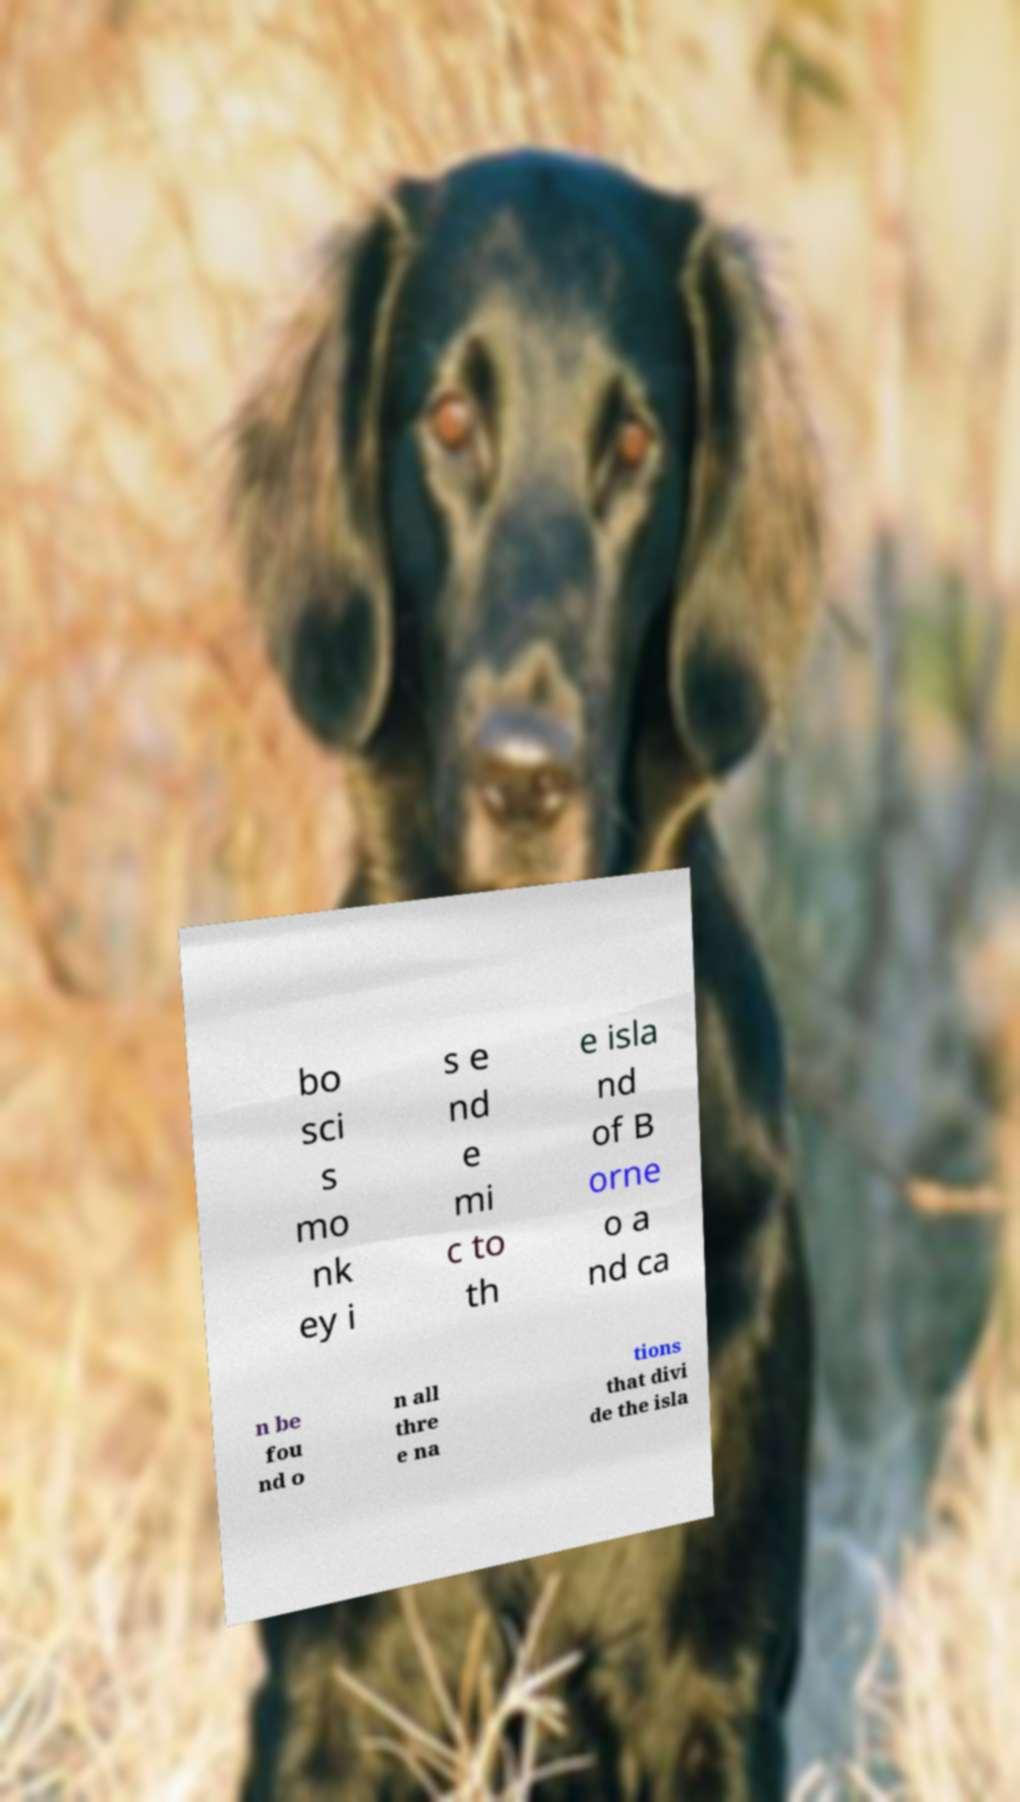Could you extract and type out the text from this image? bo sci s mo nk ey i s e nd e mi c to th e isla nd of B orne o a nd ca n be fou nd o n all thre e na tions that divi de the isla 